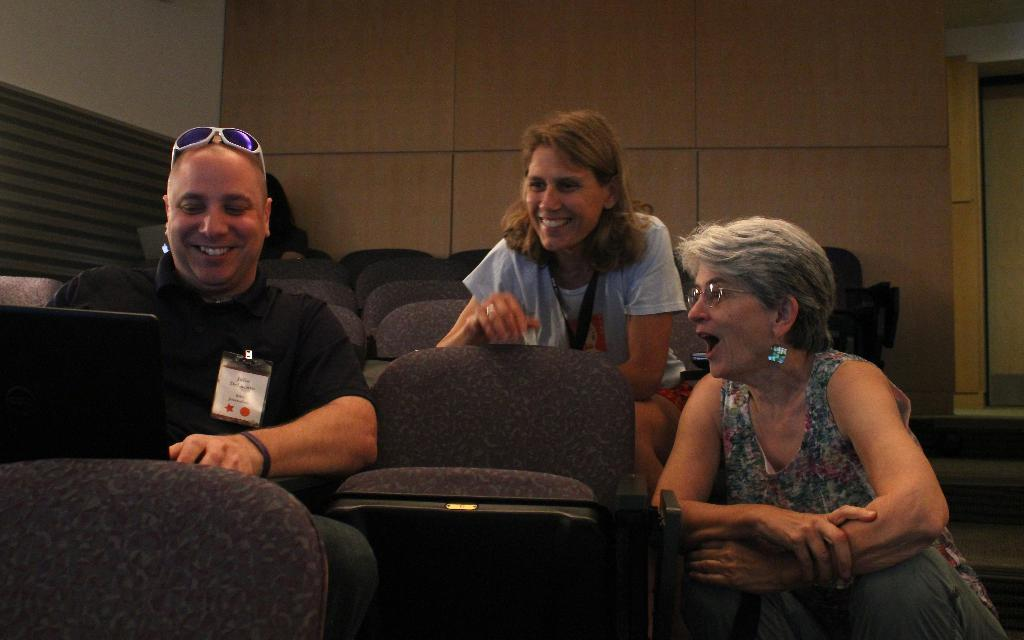What are the people in the image doing? The people in the image are sitting. What are the people sitting on? There are chairs in the image. What can be seen in the background of the image? There is a wall in the background of the image. What is on the right side of the image? There is a door on the right side of the image. What type of quilt is draped over the door in the image? There is no quilt present in the image; the door is not covered by any fabric. 